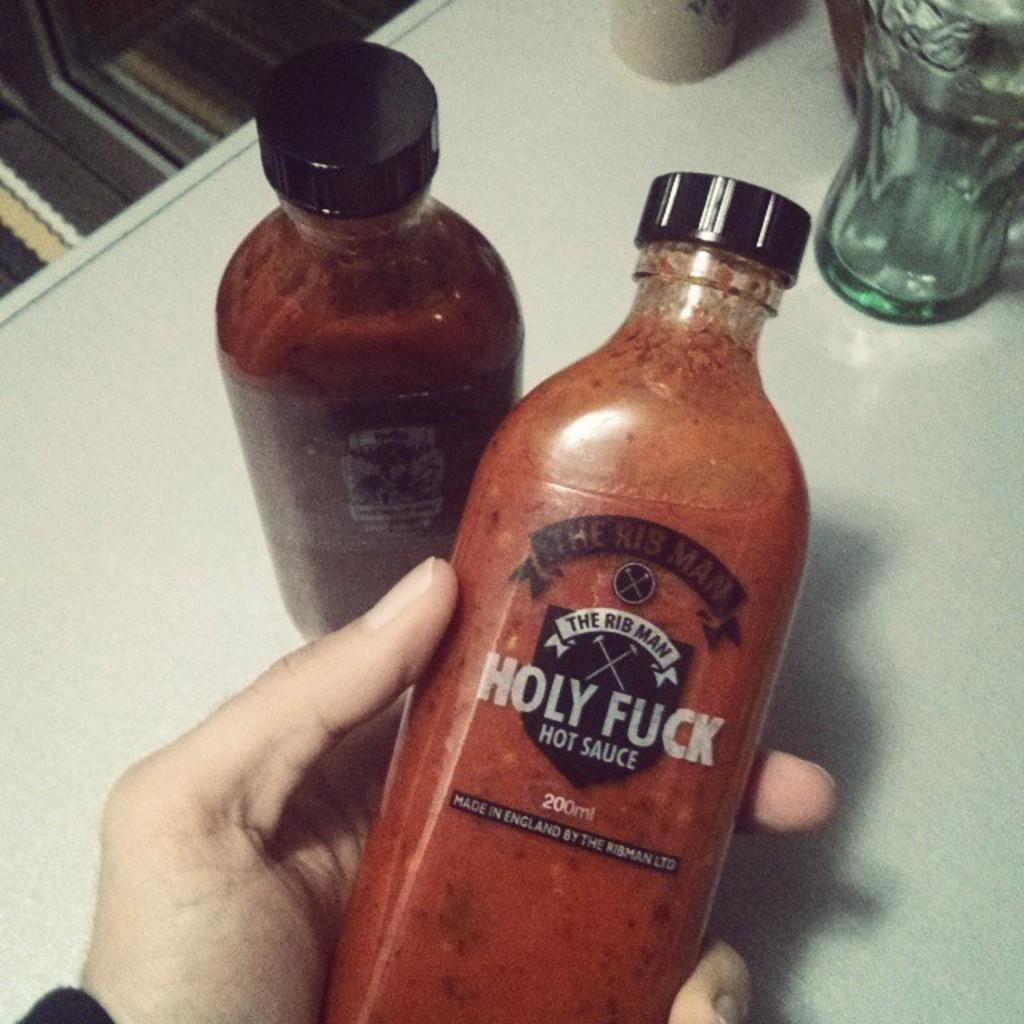<image>
Give a short and clear explanation of the subsequent image. A hand holding up a bottle of Holy Fu*k hot sauce with a black bottle top. 